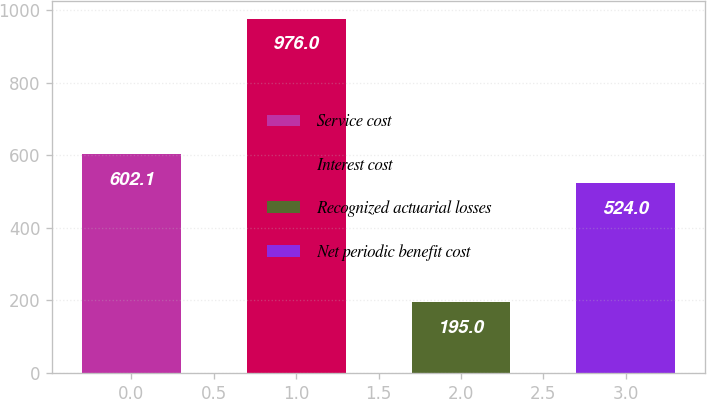<chart> <loc_0><loc_0><loc_500><loc_500><bar_chart><fcel>Service cost<fcel>Interest cost<fcel>Recognized actuarial losses<fcel>Net periodic benefit cost<nl><fcel>602.1<fcel>976<fcel>195<fcel>524<nl></chart> 